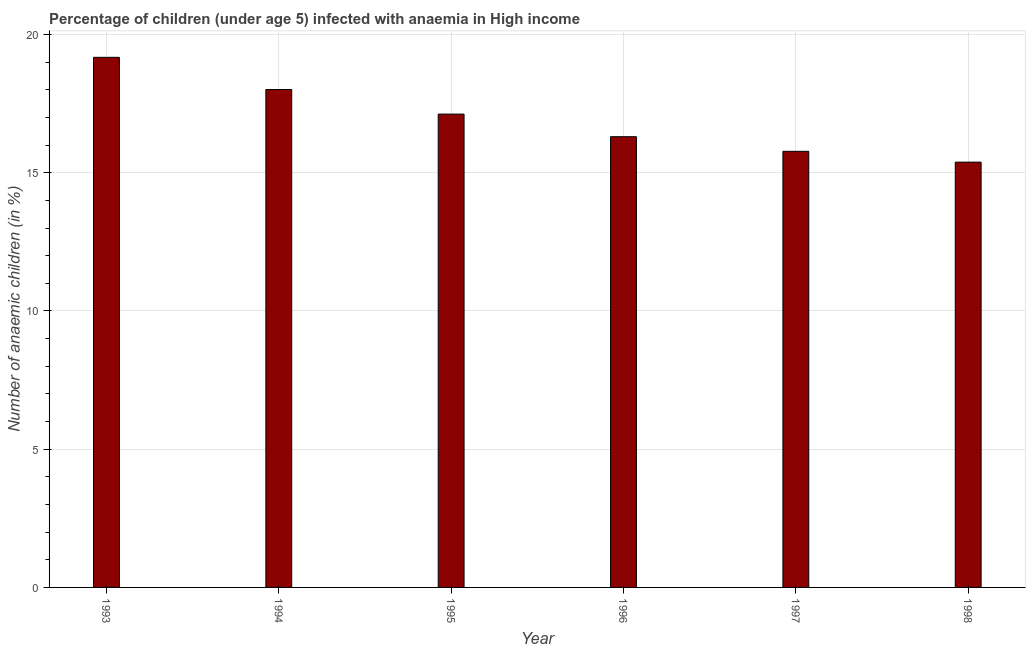Does the graph contain any zero values?
Make the answer very short. No. What is the title of the graph?
Provide a succinct answer. Percentage of children (under age 5) infected with anaemia in High income. What is the label or title of the Y-axis?
Ensure brevity in your answer.  Number of anaemic children (in %). What is the number of anaemic children in 1995?
Ensure brevity in your answer.  17.12. Across all years, what is the maximum number of anaemic children?
Make the answer very short. 19.17. Across all years, what is the minimum number of anaemic children?
Provide a short and direct response. 15.38. In which year was the number of anaemic children minimum?
Your answer should be compact. 1998. What is the sum of the number of anaemic children?
Provide a succinct answer. 101.77. What is the difference between the number of anaemic children in 1997 and 1998?
Offer a terse response. 0.39. What is the average number of anaemic children per year?
Provide a short and direct response. 16.96. What is the median number of anaemic children?
Your answer should be very brief. 16.71. What is the ratio of the number of anaemic children in 1994 to that in 1996?
Provide a succinct answer. 1.1. Is the difference between the number of anaemic children in 1994 and 1998 greater than the difference between any two years?
Offer a terse response. No. What is the difference between the highest and the second highest number of anaemic children?
Provide a succinct answer. 1.16. What is the difference between the highest and the lowest number of anaemic children?
Offer a very short reply. 3.79. In how many years, is the number of anaemic children greater than the average number of anaemic children taken over all years?
Make the answer very short. 3. How many bars are there?
Provide a succinct answer. 6. How many years are there in the graph?
Provide a short and direct response. 6. Are the values on the major ticks of Y-axis written in scientific E-notation?
Your answer should be very brief. No. What is the Number of anaemic children (in %) in 1993?
Make the answer very short. 19.17. What is the Number of anaemic children (in %) in 1994?
Offer a very short reply. 18.01. What is the Number of anaemic children (in %) in 1995?
Give a very brief answer. 17.12. What is the Number of anaemic children (in %) of 1996?
Provide a succinct answer. 16.3. What is the Number of anaemic children (in %) of 1997?
Keep it short and to the point. 15.77. What is the Number of anaemic children (in %) in 1998?
Ensure brevity in your answer.  15.38. What is the difference between the Number of anaemic children (in %) in 1993 and 1994?
Keep it short and to the point. 1.16. What is the difference between the Number of anaemic children (in %) in 1993 and 1995?
Your answer should be very brief. 2.05. What is the difference between the Number of anaemic children (in %) in 1993 and 1996?
Ensure brevity in your answer.  2.87. What is the difference between the Number of anaemic children (in %) in 1993 and 1997?
Your answer should be very brief. 3.4. What is the difference between the Number of anaemic children (in %) in 1993 and 1998?
Your answer should be compact. 3.79. What is the difference between the Number of anaemic children (in %) in 1994 and 1995?
Ensure brevity in your answer.  0.89. What is the difference between the Number of anaemic children (in %) in 1994 and 1996?
Offer a very short reply. 1.71. What is the difference between the Number of anaemic children (in %) in 1994 and 1997?
Make the answer very short. 2.24. What is the difference between the Number of anaemic children (in %) in 1994 and 1998?
Keep it short and to the point. 2.63. What is the difference between the Number of anaemic children (in %) in 1995 and 1996?
Your answer should be compact. 0.82. What is the difference between the Number of anaemic children (in %) in 1995 and 1997?
Your response must be concise. 1.35. What is the difference between the Number of anaemic children (in %) in 1995 and 1998?
Ensure brevity in your answer.  1.74. What is the difference between the Number of anaemic children (in %) in 1996 and 1997?
Offer a terse response. 0.53. What is the difference between the Number of anaemic children (in %) in 1996 and 1998?
Make the answer very short. 0.92. What is the difference between the Number of anaemic children (in %) in 1997 and 1998?
Your answer should be compact. 0.39. What is the ratio of the Number of anaemic children (in %) in 1993 to that in 1994?
Make the answer very short. 1.06. What is the ratio of the Number of anaemic children (in %) in 1993 to that in 1995?
Give a very brief answer. 1.12. What is the ratio of the Number of anaemic children (in %) in 1993 to that in 1996?
Your answer should be compact. 1.18. What is the ratio of the Number of anaemic children (in %) in 1993 to that in 1997?
Give a very brief answer. 1.22. What is the ratio of the Number of anaemic children (in %) in 1993 to that in 1998?
Your answer should be compact. 1.25. What is the ratio of the Number of anaemic children (in %) in 1994 to that in 1995?
Provide a succinct answer. 1.05. What is the ratio of the Number of anaemic children (in %) in 1994 to that in 1996?
Provide a succinct answer. 1.1. What is the ratio of the Number of anaemic children (in %) in 1994 to that in 1997?
Provide a succinct answer. 1.14. What is the ratio of the Number of anaemic children (in %) in 1994 to that in 1998?
Ensure brevity in your answer.  1.17. What is the ratio of the Number of anaemic children (in %) in 1995 to that in 1997?
Your response must be concise. 1.08. What is the ratio of the Number of anaemic children (in %) in 1995 to that in 1998?
Give a very brief answer. 1.11. What is the ratio of the Number of anaemic children (in %) in 1996 to that in 1997?
Ensure brevity in your answer.  1.03. What is the ratio of the Number of anaemic children (in %) in 1996 to that in 1998?
Provide a succinct answer. 1.06. 